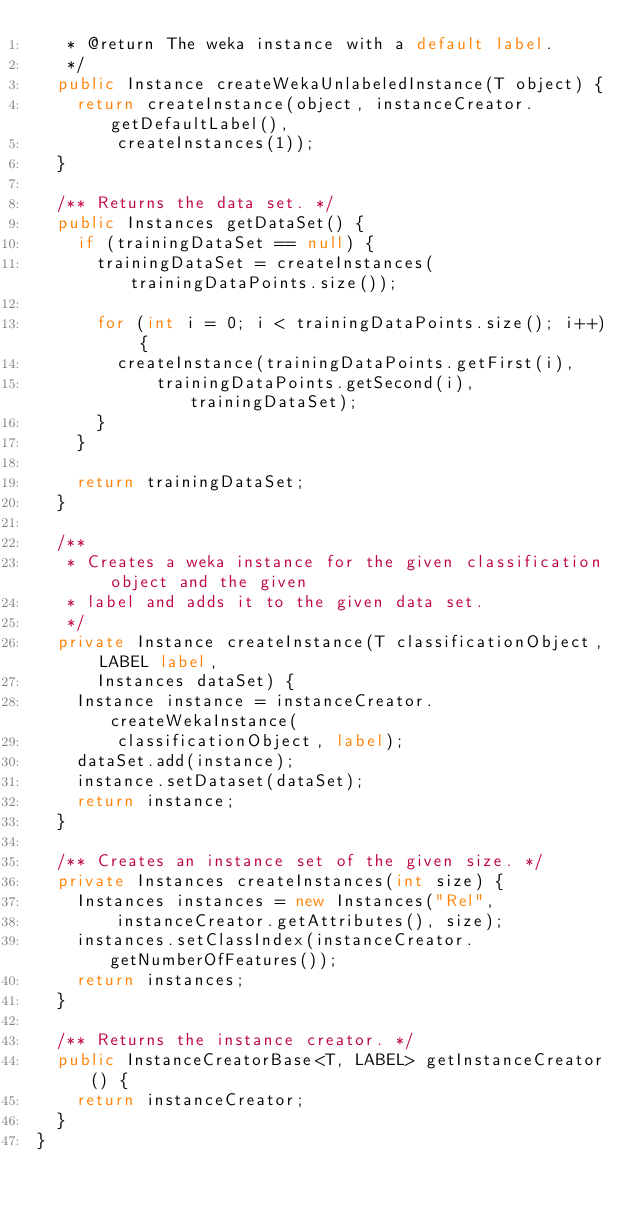Convert code to text. <code><loc_0><loc_0><loc_500><loc_500><_Java_>	 * @return The weka instance with a default label.
	 */
	public Instance createWekaUnlabeledInstance(T object) {
		return createInstance(object, instanceCreator.getDefaultLabel(),
				createInstances(1));
	}

	/** Returns the data set. */
	public Instances getDataSet() {
		if (trainingDataSet == null) {
			trainingDataSet = createInstances(trainingDataPoints.size());

			for (int i = 0; i < trainingDataPoints.size(); i++) {
				createInstance(trainingDataPoints.getFirst(i),
						trainingDataPoints.getSecond(i), trainingDataSet);
			}
		}

		return trainingDataSet;
	}

	/**
	 * Creates a weka instance for the given classification object and the given
	 * label and adds it to the given data set.
	 */
	private Instance createInstance(T classificationObject, LABEL label,
			Instances dataSet) {
		Instance instance = instanceCreator.createWekaInstance(
				classificationObject, label);
		dataSet.add(instance);
		instance.setDataset(dataSet);
		return instance;
	}

	/** Creates an instance set of the given size. */
	private Instances createInstances(int size) {
		Instances instances = new Instances("Rel",
				instanceCreator.getAttributes(), size);
		instances.setClassIndex(instanceCreator.getNumberOfFeatures());
		return instances;
	}

	/** Returns the instance creator. */
	public InstanceCreatorBase<T, LABEL> getInstanceCreator() {
		return instanceCreator;
	}
}
</code> 